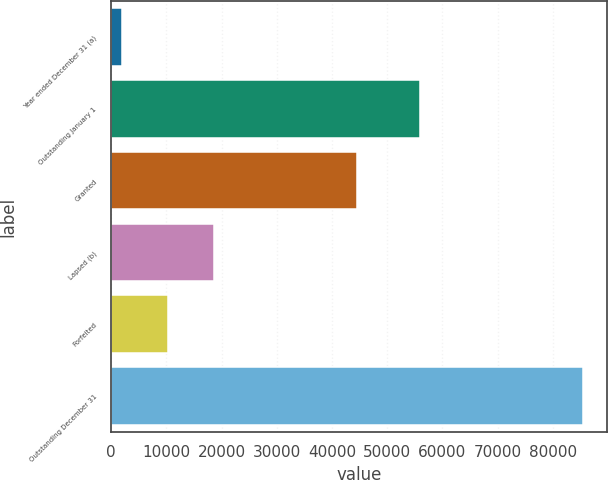<chart> <loc_0><loc_0><loc_500><loc_500><bar_chart><fcel>Year ended December 31 (a)<fcel>Outstanding January 1<fcel>Granted<fcel>Lapsed (b)<fcel>Forfeited<fcel>Outstanding December 31<nl><fcel>2003<fcel>55886<fcel>44552<fcel>18707.8<fcel>10355.4<fcel>85527<nl></chart> 